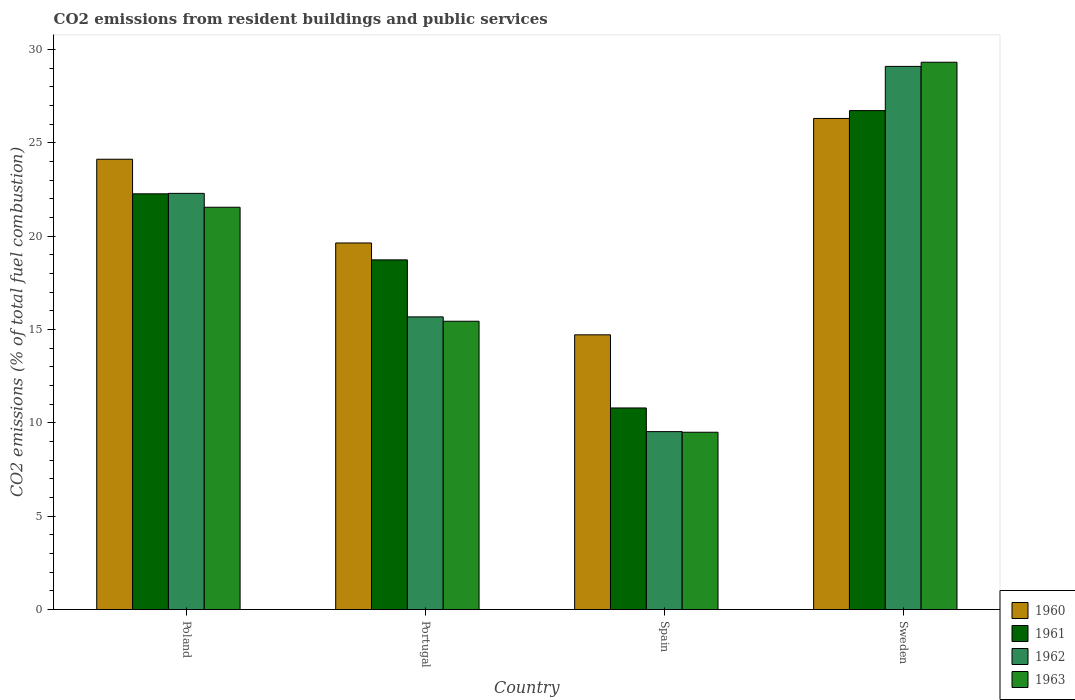How many different coloured bars are there?
Provide a short and direct response. 4. How many groups of bars are there?
Your response must be concise. 4. Are the number of bars per tick equal to the number of legend labels?
Make the answer very short. Yes. What is the label of the 4th group of bars from the left?
Offer a very short reply. Sweden. In how many cases, is the number of bars for a given country not equal to the number of legend labels?
Your answer should be very brief. 0. What is the total CO2 emitted in 1962 in Spain?
Offer a terse response. 9.53. Across all countries, what is the maximum total CO2 emitted in 1961?
Offer a very short reply. 26.73. Across all countries, what is the minimum total CO2 emitted in 1960?
Your response must be concise. 14.72. In which country was the total CO2 emitted in 1960 maximum?
Your answer should be very brief. Sweden. In which country was the total CO2 emitted in 1961 minimum?
Your response must be concise. Spain. What is the total total CO2 emitted in 1961 in the graph?
Your answer should be very brief. 78.53. What is the difference between the total CO2 emitted in 1963 in Portugal and that in Spain?
Make the answer very short. 5.95. What is the difference between the total CO2 emitted in 1961 in Portugal and the total CO2 emitted in 1960 in Poland?
Give a very brief answer. -5.39. What is the average total CO2 emitted in 1962 per country?
Provide a short and direct response. 19.15. What is the difference between the total CO2 emitted of/in 1961 and total CO2 emitted of/in 1963 in Portugal?
Your answer should be very brief. 3.29. What is the ratio of the total CO2 emitted in 1962 in Spain to that in Sweden?
Keep it short and to the point. 0.33. Is the total CO2 emitted in 1960 in Portugal less than that in Sweden?
Offer a very short reply. Yes. Is the difference between the total CO2 emitted in 1961 in Poland and Sweden greater than the difference between the total CO2 emitted in 1963 in Poland and Sweden?
Make the answer very short. Yes. What is the difference between the highest and the second highest total CO2 emitted in 1962?
Ensure brevity in your answer.  6.8. What is the difference between the highest and the lowest total CO2 emitted in 1962?
Make the answer very short. 19.57. In how many countries, is the total CO2 emitted in 1963 greater than the average total CO2 emitted in 1963 taken over all countries?
Ensure brevity in your answer.  2. Is the sum of the total CO2 emitted in 1963 in Portugal and Spain greater than the maximum total CO2 emitted in 1960 across all countries?
Provide a succinct answer. No. Is it the case that in every country, the sum of the total CO2 emitted in 1960 and total CO2 emitted in 1961 is greater than the sum of total CO2 emitted in 1963 and total CO2 emitted in 1962?
Provide a succinct answer. No. Is it the case that in every country, the sum of the total CO2 emitted in 1963 and total CO2 emitted in 1960 is greater than the total CO2 emitted in 1962?
Your response must be concise. Yes. What is the difference between two consecutive major ticks on the Y-axis?
Keep it short and to the point. 5. Are the values on the major ticks of Y-axis written in scientific E-notation?
Offer a very short reply. No. Does the graph contain grids?
Offer a very short reply. No. How many legend labels are there?
Your answer should be very brief. 4. How are the legend labels stacked?
Provide a succinct answer. Vertical. What is the title of the graph?
Your answer should be compact. CO2 emissions from resident buildings and public services. Does "2007" appear as one of the legend labels in the graph?
Your response must be concise. No. What is the label or title of the Y-axis?
Your response must be concise. CO2 emissions (% of total fuel combustion). What is the CO2 emissions (% of total fuel combustion) of 1960 in Poland?
Provide a short and direct response. 24.12. What is the CO2 emissions (% of total fuel combustion) of 1961 in Poland?
Provide a succinct answer. 22.27. What is the CO2 emissions (% of total fuel combustion) of 1962 in Poland?
Your response must be concise. 22.3. What is the CO2 emissions (% of total fuel combustion) in 1963 in Poland?
Ensure brevity in your answer.  21.55. What is the CO2 emissions (% of total fuel combustion) of 1960 in Portugal?
Your answer should be compact. 19.64. What is the CO2 emissions (% of total fuel combustion) of 1961 in Portugal?
Provide a succinct answer. 18.73. What is the CO2 emissions (% of total fuel combustion) in 1962 in Portugal?
Give a very brief answer. 15.68. What is the CO2 emissions (% of total fuel combustion) of 1963 in Portugal?
Ensure brevity in your answer.  15.44. What is the CO2 emissions (% of total fuel combustion) of 1960 in Spain?
Offer a very short reply. 14.72. What is the CO2 emissions (% of total fuel combustion) of 1961 in Spain?
Ensure brevity in your answer.  10.8. What is the CO2 emissions (% of total fuel combustion) in 1962 in Spain?
Your response must be concise. 9.53. What is the CO2 emissions (% of total fuel combustion) in 1963 in Spain?
Keep it short and to the point. 9.5. What is the CO2 emissions (% of total fuel combustion) in 1960 in Sweden?
Keep it short and to the point. 26.31. What is the CO2 emissions (% of total fuel combustion) in 1961 in Sweden?
Your answer should be very brief. 26.73. What is the CO2 emissions (% of total fuel combustion) of 1962 in Sweden?
Provide a succinct answer. 29.1. What is the CO2 emissions (% of total fuel combustion) of 1963 in Sweden?
Your answer should be compact. 29.32. Across all countries, what is the maximum CO2 emissions (% of total fuel combustion) of 1960?
Provide a short and direct response. 26.31. Across all countries, what is the maximum CO2 emissions (% of total fuel combustion) of 1961?
Your answer should be very brief. 26.73. Across all countries, what is the maximum CO2 emissions (% of total fuel combustion) of 1962?
Provide a succinct answer. 29.1. Across all countries, what is the maximum CO2 emissions (% of total fuel combustion) in 1963?
Provide a succinct answer. 29.32. Across all countries, what is the minimum CO2 emissions (% of total fuel combustion) in 1960?
Your answer should be compact. 14.72. Across all countries, what is the minimum CO2 emissions (% of total fuel combustion) of 1961?
Make the answer very short. 10.8. Across all countries, what is the minimum CO2 emissions (% of total fuel combustion) of 1962?
Keep it short and to the point. 9.53. Across all countries, what is the minimum CO2 emissions (% of total fuel combustion) in 1963?
Ensure brevity in your answer.  9.5. What is the total CO2 emissions (% of total fuel combustion) of 1960 in the graph?
Offer a very short reply. 84.79. What is the total CO2 emissions (% of total fuel combustion) of 1961 in the graph?
Your answer should be very brief. 78.53. What is the total CO2 emissions (% of total fuel combustion) in 1962 in the graph?
Offer a terse response. 76.6. What is the total CO2 emissions (% of total fuel combustion) of 1963 in the graph?
Provide a succinct answer. 75.81. What is the difference between the CO2 emissions (% of total fuel combustion) of 1960 in Poland and that in Portugal?
Ensure brevity in your answer.  4.49. What is the difference between the CO2 emissions (% of total fuel combustion) of 1961 in Poland and that in Portugal?
Offer a terse response. 3.54. What is the difference between the CO2 emissions (% of total fuel combustion) of 1962 in Poland and that in Portugal?
Your answer should be compact. 6.62. What is the difference between the CO2 emissions (% of total fuel combustion) of 1963 in Poland and that in Portugal?
Make the answer very short. 6.11. What is the difference between the CO2 emissions (% of total fuel combustion) of 1960 in Poland and that in Spain?
Offer a very short reply. 9.41. What is the difference between the CO2 emissions (% of total fuel combustion) in 1961 in Poland and that in Spain?
Give a very brief answer. 11.47. What is the difference between the CO2 emissions (% of total fuel combustion) in 1962 in Poland and that in Spain?
Your answer should be very brief. 12.76. What is the difference between the CO2 emissions (% of total fuel combustion) of 1963 in Poland and that in Spain?
Your answer should be compact. 12.05. What is the difference between the CO2 emissions (% of total fuel combustion) of 1960 in Poland and that in Sweden?
Ensure brevity in your answer.  -2.19. What is the difference between the CO2 emissions (% of total fuel combustion) in 1961 in Poland and that in Sweden?
Give a very brief answer. -4.46. What is the difference between the CO2 emissions (% of total fuel combustion) in 1962 in Poland and that in Sweden?
Provide a succinct answer. -6.8. What is the difference between the CO2 emissions (% of total fuel combustion) in 1963 in Poland and that in Sweden?
Provide a short and direct response. -7.77. What is the difference between the CO2 emissions (% of total fuel combustion) of 1960 in Portugal and that in Spain?
Give a very brief answer. 4.92. What is the difference between the CO2 emissions (% of total fuel combustion) of 1961 in Portugal and that in Spain?
Keep it short and to the point. 7.93. What is the difference between the CO2 emissions (% of total fuel combustion) in 1962 in Portugal and that in Spain?
Ensure brevity in your answer.  6.15. What is the difference between the CO2 emissions (% of total fuel combustion) of 1963 in Portugal and that in Spain?
Offer a very short reply. 5.95. What is the difference between the CO2 emissions (% of total fuel combustion) of 1960 in Portugal and that in Sweden?
Give a very brief answer. -6.67. What is the difference between the CO2 emissions (% of total fuel combustion) of 1961 in Portugal and that in Sweden?
Your answer should be very brief. -8. What is the difference between the CO2 emissions (% of total fuel combustion) in 1962 in Portugal and that in Sweden?
Make the answer very short. -13.42. What is the difference between the CO2 emissions (% of total fuel combustion) of 1963 in Portugal and that in Sweden?
Keep it short and to the point. -13.88. What is the difference between the CO2 emissions (% of total fuel combustion) of 1960 in Spain and that in Sweden?
Give a very brief answer. -11.59. What is the difference between the CO2 emissions (% of total fuel combustion) of 1961 in Spain and that in Sweden?
Your answer should be compact. -15.93. What is the difference between the CO2 emissions (% of total fuel combustion) of 1962 in Spain and that in Sweden?
Give a very brief answer. -19.57. What is the difference between the CO2 emissions (% of total fuel combustion) of 1963 in Spain and that in Sweden?
Your response must be concise. -19.82. What is the difference between the CO2 emissions (% of total fuel combustion) in 1960 in Poland and the CO2 emissions (% of total fuel combustion) in 1961 in Portugal?
Give a very brief answer. 5.39. What is the difference between the CO2 emissions (% of total fuel combustion) in 1960 in Poland and the CO2 emissions (% of total fuel combustion) in 1962 in Portugal?
Ensure brevity in your answer.  8.44. What is the difference between the CO2 emissions (% of total fuel combustion) in 1960 in Poland and the CO2 emissions (% of total fuel combustion) in 1963 in Portugal?
Provide a short and direct response. 8.68. What is the difference between the CO2 emissions (% of total fuel combustion) of 1961 in Poland and the CO2 emissions (% of total fuel combustion) of 1962 in Portugal?
Offer a very short reply. 6.59. What is the difference between the CO2 emissions (% of total fuel combustion) of 1961 in Poland and the CO2 emissions (% of total fuel combustion) of 1963 in Portugal?
Offer a terse response. 6.83. What is the difference between the CO2 emissions (% of total fuel combustion) of 1962 in Poland and the CO2 emissions (% of total fuel combustion) of 1963 in Portugal?
Make the answer very short. 6.85. What is the difference between the CO2 emissions (% of total fuel combustion) in 1960 in Poland and the CO2 emissions (% of total fuel combustion) in 1961 in Spain?
Your answer should be compact. 13.32. What is the difference between the CO2 emissions (% of total fuel combustion) in 1960 in Poland and the CO2 emissions (% of total fuel combustion) in 1962 in Spain?
Keep it short and to the point. 14.59. What is the difference between the CO2 emissions (% of total fuel combustion) in 1960 in Poland and the CO2 emissions (% of total fuel combustion) in 1963 in Spain?
Provide a short and direct response. 14.63. What is the difference between the CO2 emissions (% of total fuel combustion) in 1961 in Poland and the CO2 emissions (% of total fuel combustion) in 1962 in Spain?
Keep it short and to the point. 12.74. What is the difference between the CO2 emissions (% of total fuel combustion) of 1961 in Poland and the CO2 emissions (% of total fuel combustion) of 1963 in Spain?
Offer a terse response. 12.77. What is the difference between the CO2 emissions (% of total fuel combustion) of 1962 in Poland and the CO2 emissions (% of total fuel combustion) of 1963 in Spain?
Ensure brevity in your answer.  12.8. What is the difference between the CO2 emissions (% of total fuel combustion) in 1960 in Poland and the CO2 emissions (% of total fuel combustion) in 1961 in Sweden?
Offer a terse response. -2.61. What is the difference between the CO2 emissions (% of total fuel combustion) of 1960 in Poland and the CO2 emissions (% of total fuel combustion) of 1962 in Sweden?
Keep it short and to the point. -4.97. What is the difference between the CO2 emissions (% of total fuel combustion) of 1960 in Poland and the CO2 emissions (% of total fuel combustion) of 1963 in Sweden?
Your answer should be very brief. -5.2. What is the difference between the CO2 emissions (% of total fuel combustion) of 1961 in Poland and the CO2 emissions (% of total fuel combustion) of 1962 in Sweden?
Keep it short and to the point. -6.83. What is the difference between the CO2 emissions (% of total fuel combustion) of 1961 in Poland and the CO2 emissions (% of total fuel combustion) of 1963 in Sweden?
Make the answer very short. -7.05. What is the difference between the CO2 emissions (% of total fuel combustion) of 1962 in Poland and the CO2 emissions (% of total fuel combustion) of 1963 in Sweden?
Provide a short and direct response. -7.02. What is the difference between the CO2 emissions (% of total fuel combustion) of 1960 in Portugal and the CO2 emissions (% of total fuel combustion) of 1961 in Spain?
Ensure brevity in your answer.  8.84. What is the difference between the CO2 emissions (% of total fuel combustion) of 1960 in Portugal and the CO2 emissions (% of total fuel combustion) of 1962 in Spain?
Provide a short and direct response. 10.11. What is the difference between the CO2 emissions (% of total fuel combustion) in 1960 in Portugal and the CO2 emissions (% of total fuel combustion) in 1963 in Spain?
Offer a very short reply. 10.14. What is the difference between the CO2 emissions (% of total fuel combustion) of 1961 in Portugal and the CO2 emissions (% of total fuel combustion) of 1962 in Spain?
Make the answer very short. 9.2. What is the difference between the CO2 emissions (% of total fuel combustion) in 1961 in Portugal and the CO2 emissions (% of total fuel combustion) in 1963 in Spain?
Your answer should be compact. 9.23. What is the difference between the CO2 emissions (% of total fuel combustion) of 1962 in Portugal and the CO2 emissions (% of total fuel combustion) of 1963 in Spain?
Offer a terse response. 6.18. What is the difference between the CO2 emissions (% of total fuel combustion) in 1960 in Portugal and the CO2 emissions (% of total fuel combustion) in 1961 in Sweden?
Make the answer very short. -7.09. What is the difference between the CO2 emissions (% of total fuel combustion) of 1960 in Portugal and the CO2 emissions (% of total fuel combustion) of 1962 in Sweden?
Give a very brief answer. -9.46. What is the difference between the CO2 emissions (% of total fuel combustion) of 1960 in Portugal and the CO2 emissions (% of total fuel combustion) of 1963 in Sweden?
Offer a very short reply. -9.68. What is the difference between the CO2 emissions (% of total fuel combustion) of 1961 in Portugal and the CO2 emissions (% of total fuel combustion) of 1962 in Sweden?
Ensure brevity in your answer.  -10.36. What is the difference between the CO2 emissions (% of total fuel combustion) in 1961 in Portugal and the CO2 emissions (% of total fuel combustion) in 1963 in Sweden?
Make the answer very short. -10.59. What is the difference between the CO2 emissions (% of total fuel combustion) of 1962 in Portugal and the CO2 emissions (% of total fuel combustion) of 1963 in Sweden?
Your response must be concise. -13.64. What is the difference between the CO2 emissions (% of total fuel combustion) of 1960 in Spain and the CO2 emissions (% of total fuel combustion) of 1961 in Sweden?
Ensure brevity in your answer.  -12.01. What is the difference between the CO2 emissions (% of total fuel combustion) in 1960 in Spain and the CO2 emissions (% of total fuel combustion) in 1962 in Sweden?
Make the answer very short. -14.38. What is the difference between the CO2 emissions (% of total fuel combustion) of 1960 in Spain and the CO2 emissions (% of total fuel combustion) of 1963 in Sweden?
Your answer should be very brief. -14.6. What is the difference between the CO2 emissions (% of total fuel combustion) in 1961 in Spain and the CO2 emissions (% of total fuel combustion) in 1962 in Sweden?
Offer a terse response. -18.3. What is the difference between the CO2 emissions (% of total fuel combustion) in 1961 in Spain and the CO2 emissions (% of total fuel combustion) in 1963 in Sweden?
Make the answer very short. -18.52. What is the difference between the CO2 emissions (% of total fuel combustion) in 1962 in Spain and the CO2 emissions (% of total fuel combustion) in 1963 in Sweden?
Your answer should be very brief. -19.79. What is the average CO2 emissions (% of total fuel combustion) in 1960 per country?
Your response must be concise. 21.2. What is the average CO2 emissions (% of total fuel combustion) in 1961 per country?
Provide a succinct answer. 19.63. What is the average CO2 emissions (% of total fuel combustion) of 1962 per country?
Ensure brevity in your answer.  19.15. What is the average CO2 emissions (% of total fuel combustion) of 1963 per country?
Provide a short and direct response. 18.95. What is the difference between the CO2 emissions (% of total fuel combustion) of 1960 and CO2 emissions (% of total fuel combustion) of 1961 in Poland?
Give a very brief answer. 1.85. What is the difference between the CO2 emissions (% of total fuel combustion) of 1960 and CO2 emissions (% of total fuel combustion) of 1962 in Poland?
Keep it short and to the point. 1.83. What is the difference between the CO2 emissions (% of total fuel combustion) in 1960 and CO2 emissions (% of total fuel combustion) in 1963 in Poland?
Your answer should be very brief. 2.57. What is the difference between the CO2 emissions (% of total fuel combustion) in 1961 and CO2 emissions (% of total fuel combustion) in 1962 in Poland?
Provide a succinct answer. -0.02. What is the difference between the CO2 emissions (% of total fuel combustion) of 1961 and CO2 emissions (% of total fuel combustion) of 1963 in Poland?
Give a very brief answer. 0.72. What is the difference between the CO2 emissions (% of total fuel combustion) in 1962 and CO2 emissions (% of total fuel combustion) in 1963 in Poland?
Your response must be concise. 0.74. What is the difference between the CO2 emissions (% of total fuel combustion) of 1960 and CO2 emissions (% of total fuel combustion) of 1961 in Portugal?
Your answer should be compact. 0.91. What is the difference between the CO2 emissions (% of total fuel combustion) of 1960 and CO2 emissions (% of total fuel combustion) of 1962 in Portugal?
Offer a very short reply. 3.96. What is the difference between the CO2 emissions (% of total fuel combustion) in 1960 and CO2 emissions (% of total fuel combustion) in 1963 in Portugal?
Offer a very short reply. 4.19. What is the difference between the CO2 emissions (% of total fuel combustion) in 1961 and CO2 emissions (% of total fuel combustion) in 1962 in Portugal?
Your answer should be compact. 3.05. What is the difference between the CO2 emissions (% of total fuel combustion) in 1961 and CO2 emissions (% of total fuel combustion) in 1963 in Portugal?
Offer a very short reply. 3.29. What is the difference between the CO2 emissions (% of total fuel combustion) of 1962 and CO2 emissions (% of total fuel combustion) of 1963 in Portugal?
Your answer should be compact. 0.23. What is the difference between the CO2 emissions (% of total fuel combustion) in 1960 and CO2 emissions (% of total fuel combustion) in 1961 in Spain?
Offer a very short reply. 3.92. What is the difference between the CO2 emissions (% of total fuel combustion) in 1960 and CO2 emissions (% of total fuel combustion) in 1962 in Spain?
Provide a succinct answer. 5.19. What is the difference between the CO2 emissions (% of total fuel combustion) of 1960 and CO2 emissions (% of total fuel combustion) of 1963 in Spain?
Make the answer very short. 5.22. What is the difference between the CO2 emissions (% of total fuel combustion) of 1961 and CO2 emissions (% of total fuel combustion) of 1962 in Spain?
Your answer should be compact. 1.27. What is the difference between the CO2 emissions (% of total fuel combustion) of 1961 and CO2 emissions (% of total fuel combustion) of 1963 in Spain?
Provide a succinct answer. 1.3. What is the difference between the CO2 emissions (% of total fuel combustion) in 1962 and CO2 emissions (% of total fuel combustion) in 1963 in Spain?
Your response must be concise. 0.03. What is the difference between the CO2 emissions (% of total fuel combustion) in 1960 and CO2 emissions (% of total fuel combustion) in 1961 in Sweden?
Your answer should be very brief. -0.42. What is the difference between the CO2 emissions (% of total fuel combustion) of 1960 and CO2 emissions (% of total fuel combustion) of 1962 in Sweden?
Offer a very short reply. -2.79. What is the difference between the CO2 emissions (% of total fuel combustion) in 1960 and CO2 emissions (% of total fuel combustion) in 1963 in Sweden?
Keep it short and to the point. -3.01. What is the difference between the CO2 emissions (% of total fuel combustion) of 1961 and CO2 emissions (% of total fuel combustion) of 1962 in Sweden?
Your answer should be compact. -2.37. What is the difference between the CO2 emissions (% of total fuel combustion) in 1961 and CO2 emissions (% of total fuel combustion) in 1963 in Sweden?
Make the answer very short. -2.59. What is the difference between the CO2 emissions (% of total fuel combustion) in 1962 and CO2 emissions (% of total fuel combustion) in 1963 in Sweden?
Ensure brevity in your answer.  -0.22. What is the ratio of the CO2 emissions (% of total fuel combustion) of 1960 in Poland to that in Portugal?
Offer a terse response. 1.23. What is the ratio of the CO2 emissions (% of total fuel combustion) of 1961 in Poland to that in Portugal?
Offer a terse response. 1.19. What is the ratio of the CO2 emissions (% of total fuel combustion) of 1962 in Poland to that in Portugal?
Provide a succinct answer. 1.42. What is the ratio of the CO2 emissions (% of total fuel combustion) in 1963 in Poland to that in Portugal?
Keep it short and to the point. 1.4. What is the ratio of the CO2 emissions (% of total fuel combustion) of 1960 in Poland to that in Spain?
Offer a very short reply. 1.64. What is the ratio of the CO2 emissions (% of total fuel combustion) in 1961 in Poland to that in Spain?
Provide a succinct answer. 2.06. What is the ratio of the CO2 emissions (% of total fuel combustion) in 1962 in Poland to that in Spain?
Offer a terse response. 2.34. What is the ratio of the CO2 emissions (% of total fuel combustion) in 1963 in Poland to that in Spain?
Offer a terse response. 2.27. What is the ratio of the CO2 emissions (% of total fuel combustion) of 1960 in Poland to that in Sweden?
Your response must be concise. 0.92. What is the ratio of the CO2 emissions (% of total fuel combustion) of 1961 in Poland to that in Sweden?
Offer a terse response. 0.83. What is the ratio of the CO2 emissions (% of total fuel combustion) of 1962 in Poland to that in Sweden?
Provide a short and direct response. 0.77. What is the ratio of the CO2 emissions (% of total fuel combustion) in 1963 in Poland to that in Sweden?
Provide a short and direct response. 0.73. What is the ratio of the CO2 emissions (% of total fuel combustion) in 1960 in Portugal to that in Spain?
Provide a succinct answer. 1.33. What is the ratio of the CO2 emissions (% of total fuel combustion) in 1961 in Portugal to that in Spain?
Your answer should be very brief. 1.73. What is the ratio of the CO2 emissions (% of total fuel combustion) in 1962 in Portugal to that in Spain?
Offer a terse response. 1.64. What is the ratio of the CO2 emissions (% of total fuel combustion) of 1963 in Portugal to that in Spain?
Ensure brevity in your answer.  1.63. What is the ratio of the CO2 emissions (% of total fuel combustion) in 1960 in Portugal to that in Sweden?
Provide a succinct answer. 0.75. What is the ratio of the CO2 emissions (% of total fuel combustion) of 1961 in Portugal to that in Sweden?
Your answer should be compact. 0.7. What is the ratio of the CO2 emissions (% of total fuel combustion) of 1962 in Portugal to that in Sweden?
Offer a very short reply. 0.54. What is the ratio of the CO2 emissions (% of total fuel combustion) of 1963 in Portugal to that in Sweden?
Offer a very short reply. 0.53. What is the ratio of the CO2 emissions (% of total fuel combustion) of 1960 in Spain to that in Sweden?
Offer a terse response. 0.56. What is the ratio of the CO2 emissions (% of total fuel combustion) in 1961 in Spain to that in Sweden?
Offer a very short reply. 0.4. What is the ratio of the CO2 emissions (% of total fuel combustion) in 1962 in Spain to that in Sweden?
Provide a short and direct response. 0.33. What is the ratio of the CO2 emissions (% of total fuel combustion) in 1963 in Spain to that in Sweden?
Offer a terse response. 0.32. What is the difference between the highest and the second highest CO2 emissions (% of total fuel combustion) of 1960?
Offer a terse response. 2.19. What is the difference between the highest and the second highest CO2 emissions (% of total fuel combustion) in 1961?
Provide a succinct answer. 4.46. What is the difference between the highest and the second highest CO2 emissions (% of total fuel combustion) of 1962?
Your answer should be very brief. 6.8. What is the difference between the highest and the second highest CO2 emissions (% of total fuel combustion) in 1963?
Give a very brief answer. 7.77. What is the difference between the highest and the lowest CO2 emissions (% of total fuel combustion) in 1960?
Ensure brevity in your answer.  11.59. What is the difference between the highest and the lowest CO2 emissions (% of total fuel combustion) of 1961?
Your response must be concise. 15.93. What is the difference between the highest and the lowest CO2 emissions (% of total fuel combustion) of 1962?
Your answer should be very brief. 19.57. What is the difference between the highest and the lowest CO2 emissions (% of total fuel combustion) of 1963?
Provide a short and direct response. 19.82. 